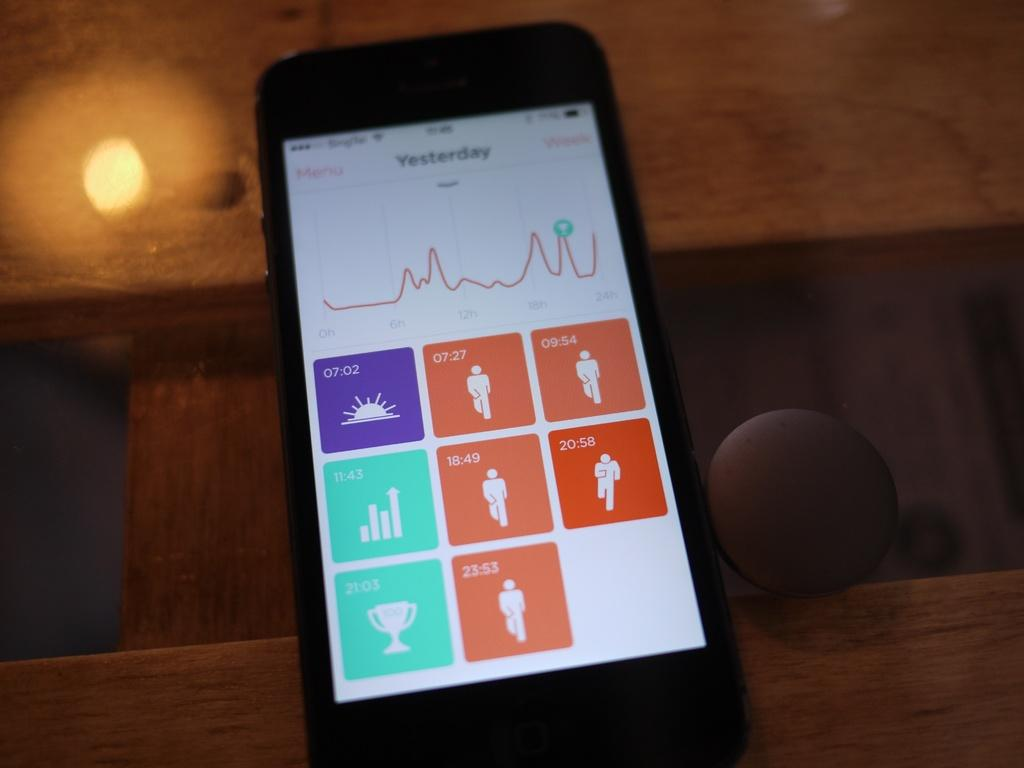<image>
Provide a brief description of the given image. a phone features a screen that says yesterday on the top with a graph beneath it 